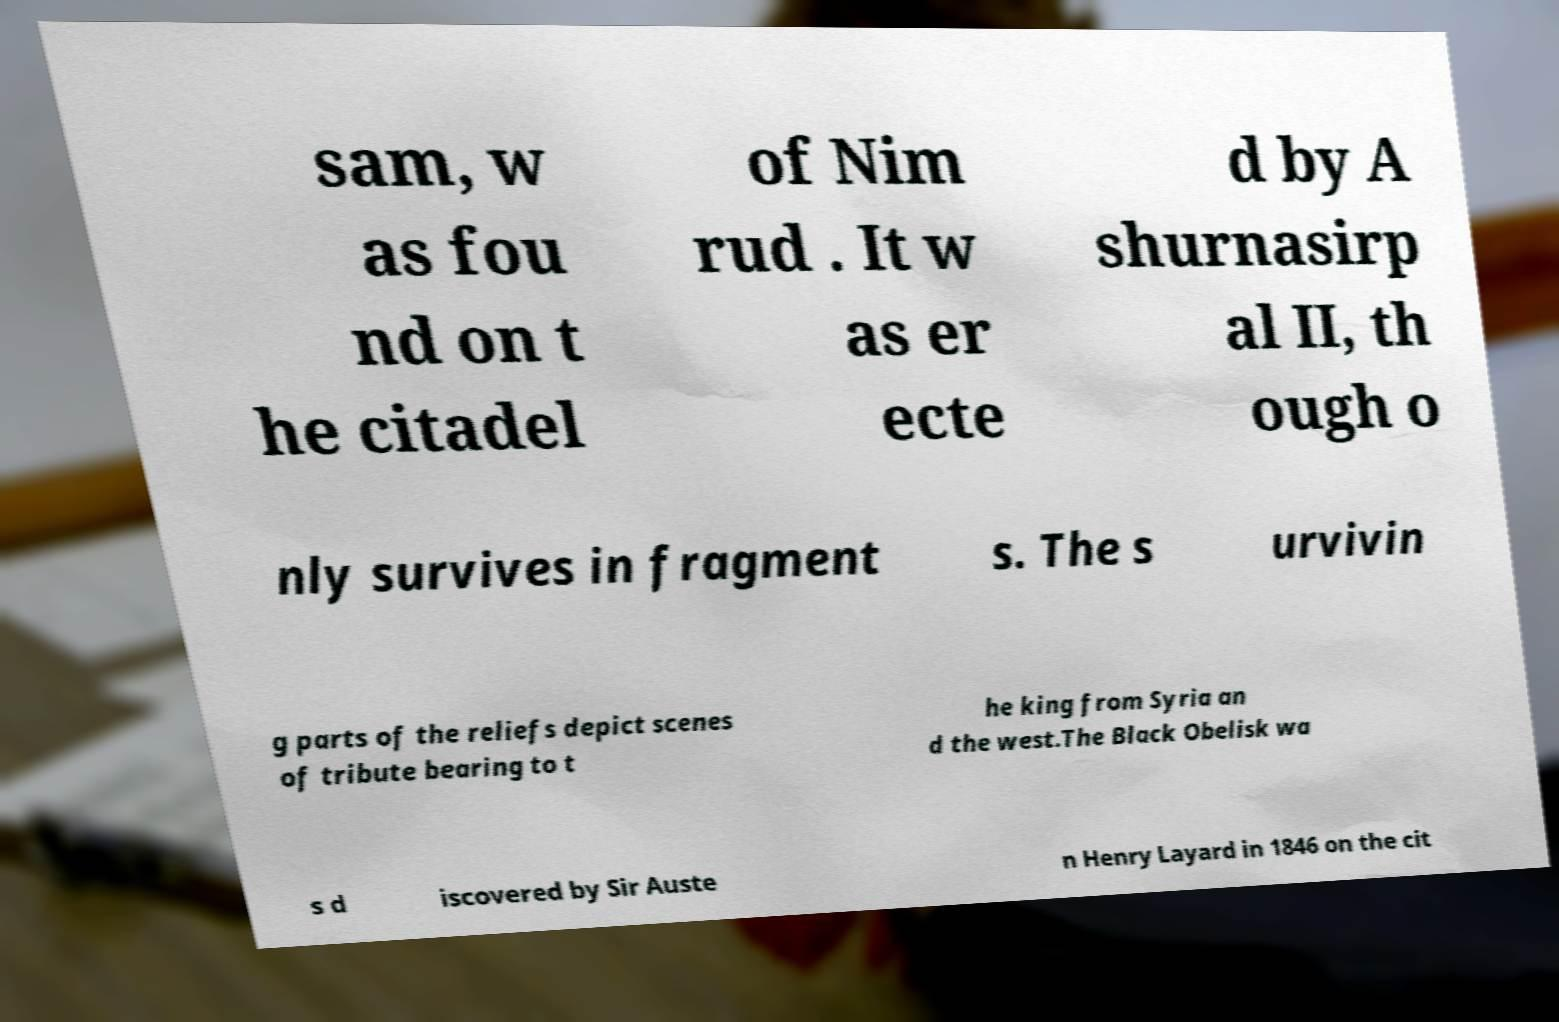For documentation purposes, I need the text within this image transcribed. Could you provide that? sam, w as fou nd on t he citadel of Nim rud . It w as er ecte d by A shurnasirp al II, th ough o nly survives in fragment s. The s urvivin g parts of the reliefs depict scenes of tribute bearing to t he king from Syria an d the west.The Black Obelisk wa s d iscovered by Sir Auste n Henry Layard in 1846 on the cit 